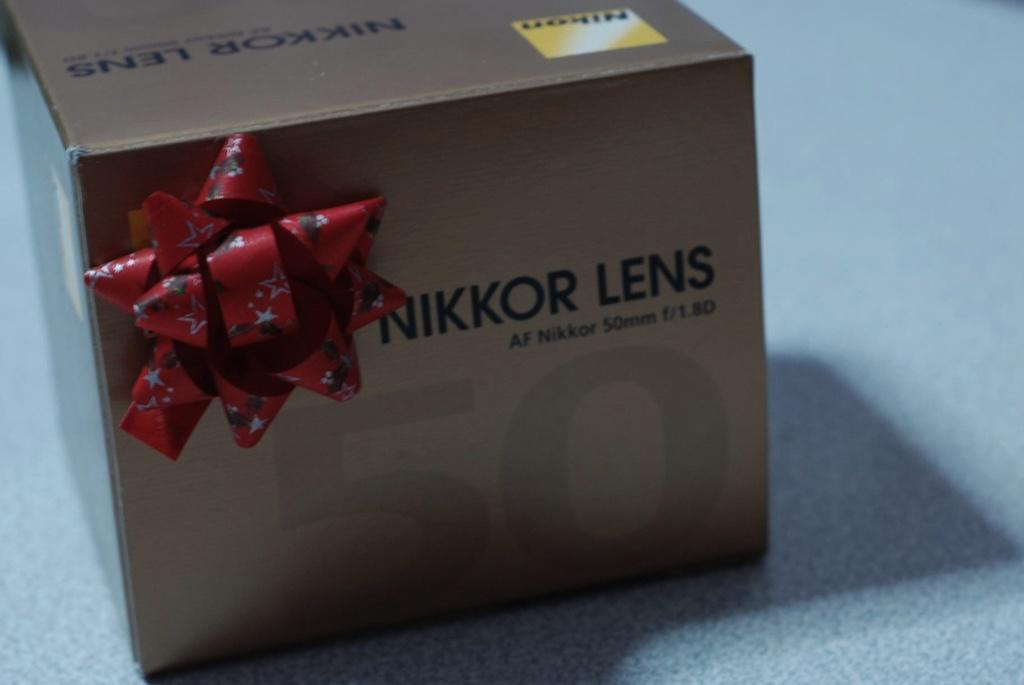<image>
Provide a brief description of the given image. a small box with a red bow on it that says 'nikkor lens' 